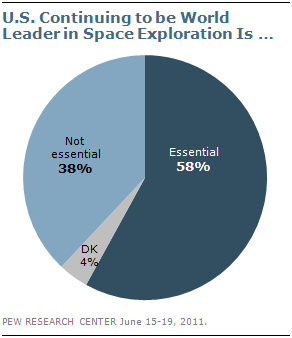Give some essential details in this illustration. The smallest section in the chart is colored gray. 